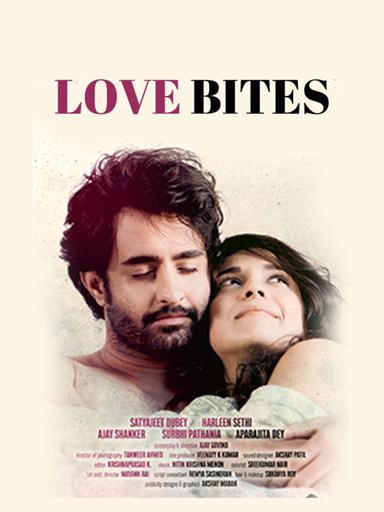Who are the actors mentioned in the "Love Bites" movie poster?
 The actors mentioned in the "Love Bites" movie poster are Satyajeet Dubey, Arleen Sethi, Aly Shaner, Surohi Pathania, and Aprajita Dey. 